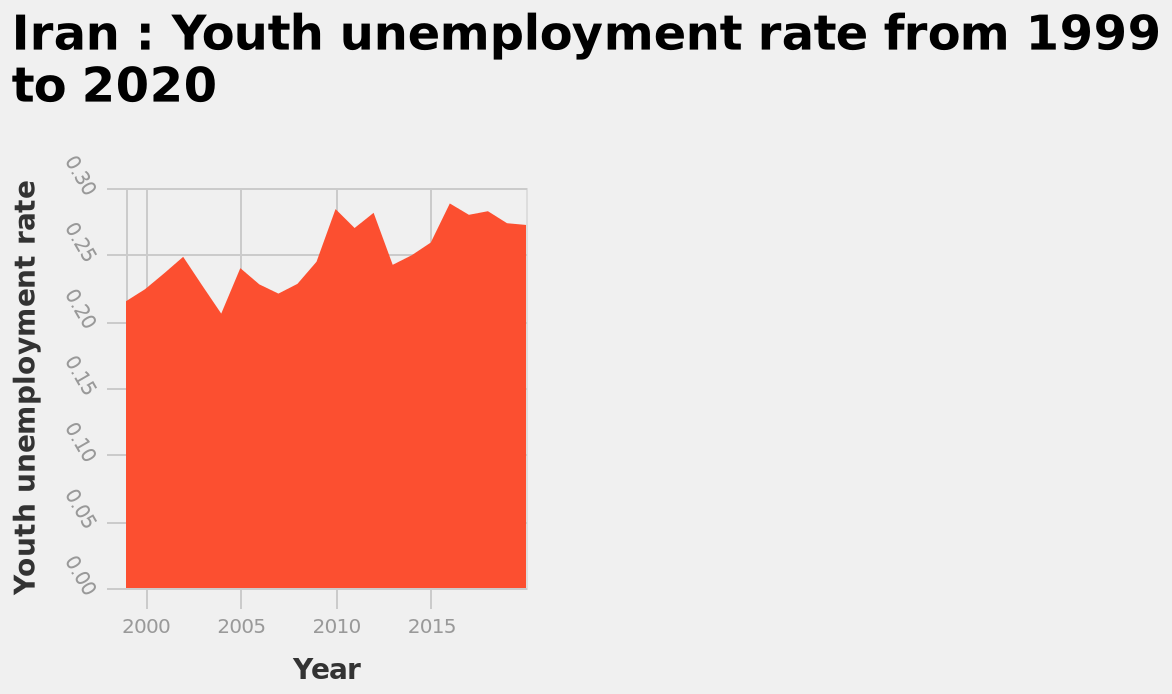<image>
What is the range of the Youth unemployment rate on the y-axis? The Youth unemployment rate ranges from 0.00 to 0.30 on the y-axis. 